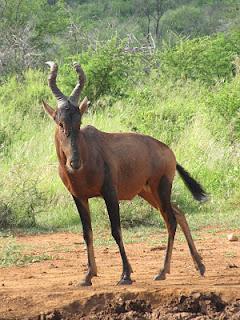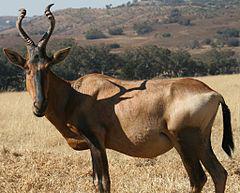The first image is the image on the left, the second image is the image on the right. Analyze the images presented: Is the assertion "Two of the animals are standing close together with heads high facing opposite directions." valid? Answer yes or no. No. The first image is the image on the left, the second image is the image on the right. Given the left and right images, does the statement "There are less than four animals with horns visible." hold true? Answer yes or no. Yes. 